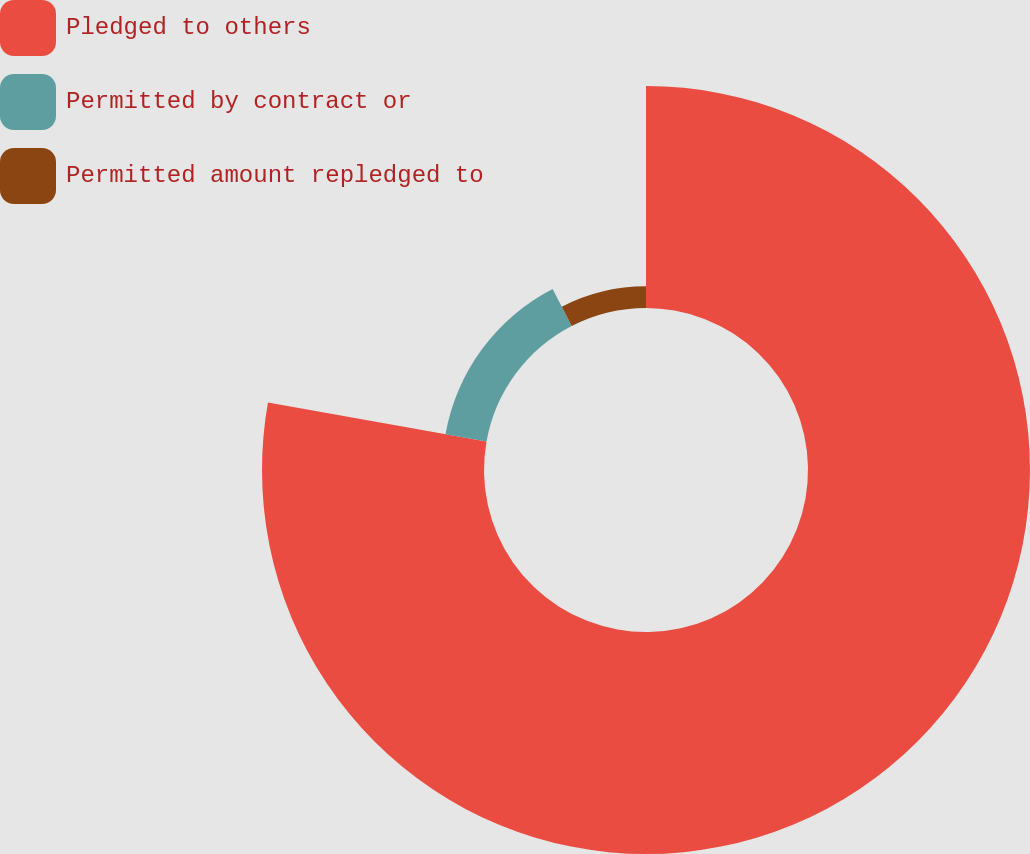Convert chart to OTSL. <chart><loc_0><loc_0><loc_500><loc_500><pie_chart><fcel>Pledged to others<fcel>Permitted by contract or<fcel>Permitted amount repledged to<nl><fcel>77.81%<fcel>14.61%<fcel>7.58%<nl></chart> 